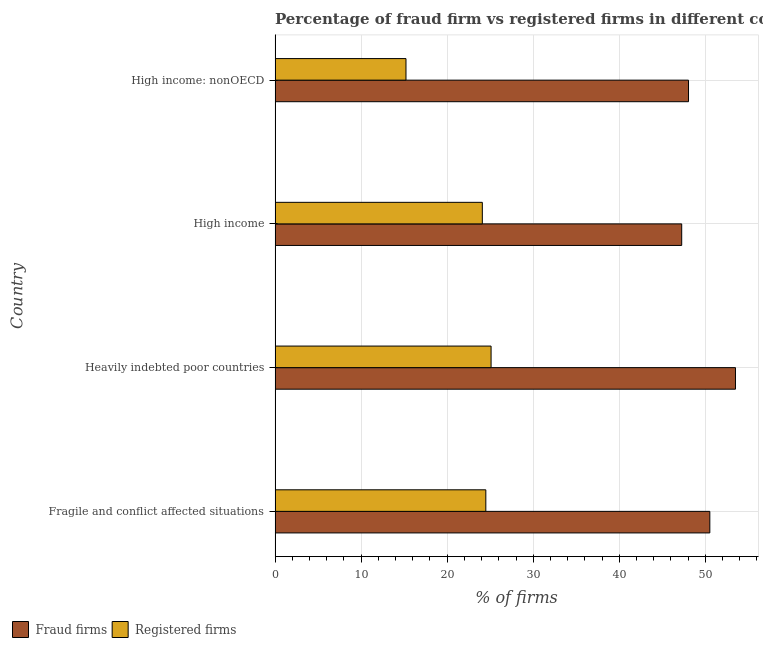How many different coloured bars are there?
Ensure brevity in your answer.  2. How many groups of bars are there?
Offer a terse response. 4. How many bars are there on the 3rd tick from the top?
Make the answer very short. 2. What is the label of the 3rd group of bars from the top?
Give a very brief answer. Heavily indebted poor countries. In how many cases, is the number of bars for a given country not equal to the number of legend labels?
Provide a succinct answer. 0. What is the percentage of registered firms in High income?
Offer a very short reply. 24.08. Across all countries, what is the maximum percentage of fraud firms?
Ensure brevity in your answer.  53.5. Across all countries, what is the minimum percentage of registered firms?
Keep it short and to the point. 15.21. In which country was the percentage of registered firms maximum?
Your response must be concise. Heavily indebted poor countries. In which country was the percentage of fraud firms minimum?
Your answer should be compact. High income. What is the total percentage of registered firms in the graph?
Provide a succinct answer. 88.89. What is the difference between the percentage of fraud firms in High income and that in High income: nonOECD?
Give a very brief answer. -0.79. What is the difference between the percentage of registered firms in High income and the percentage of fraud firms in Heavily indebted poor countries?
Your answer should be compact. -29.42. What is the average percentage of fraud firms per country?
Make the answer very short. 49.83. What is the difference between the percentage of fraud firms and percentage of registered firms in Heavily indebted poor countries?
Your response must be concise. 28.4. What is the ratio of the percentage of fraud firms in Heavily indebted poor countries to that in High income?
Keep it short and to the point. 1.13. Is the percentage of fraud firms in Fragile and conflict affected situations less than that in Heavily indebted poor countries?
Make the answer very short. Yes. What is the difference between the highest and the second highest percentage of registered firms?
Ensure brevity in your answer.  0.61. What is the difference between the highest and the lowest percentage of registered firms?
Offer a very short reply. 9.89. In how many countries, is the percentage of fraud firms greater than the average percentage of fraud firms taken over all countries?
Your answer should be compact. 2. Is the sum of the percentage of registered firms in Heavily indebted poor countries and High income greater than the maximum percentage of fraud firms across all countries?
Your answer should be very brief. No. What does the 1st bar from the top in Fragile and conflict affected situations represents?
Offer a very short reply. Registered firms. What does the 1st bar from the bottom in High income: nonOECD represents?
Provide a succinct answer. Fraud firms. How many bars are there?
Your response must be concise. 8. How many countries are there in the graph?
Make the answer very short. 4. Are the values on the major ticks of X-axis written in scientific E-notation?
Your answer should be compact. No. Does the graph contain any zero values?
Give a very brief answer. No. Does the graph contain grids?
Keep it short and to the point. Yes. Where does the legend appear in the graph?
Your answer should be compact. Bottom left. How many legend labels are there?
Offer a terse response. 2. What is the title of the graph?
Your answer should be very brief. Percentage of fraud firm vs registered firms in different countries. What is the label or title of the X-axis?
Make the answer very short. % of firms. What is the % of firms of Fraud firms in Fragile and conflict affected situations?
Your answer should be very brief. 50.52. What is the % of firms in Registered firms in Fragile and conflict affected situations?
Your answer should be very brief. 24.49. What is the % of firms in Fraud firms in Heavily indebted poor countries?
Provide a short and direct response. 53.5. What is the % of firms in Registered firms in Heavily indebted poor countries?
Give a very brief answer. 25.1. What is the % of firms of Fraud firms in High income?
Ensure brevity in your answer.  47.25. What is the % of firms in Registered firms in High income?
Your answer should be compact. 24.08. What is the % of firms in Fraud firms in High income: nonOECD?
Your answer should be very brief. 48.04. What is the % of firms in Registered firms in High income: nonOECD?
Provide a succinct answer. 15.21. Across all countries, what is the maximum % of firms in Fraud firms?
Your answer should be compact. 53.5. Across all countries, what is the maximum % of firms in Registered firms?
Your answer should be very brief. 25.1. Across all countries, what is the minimum % of firms of Fraud firms?
Offer a terse response. 47.25. Across all countries, what is the minimum % of firms in Registered firms?
Ensure brevity in your answer.  15.21. What is the total % of firms in Fraud firms in the graph?
Keep it short and to the point. 199.31. What is the total % of firms in Registered firms in the graph?
Keep it short and to the point. 88.89. What is the difference between the % of firms of Fraud firms in Fragile and conflict affected situations and that in Heavily indebted poor countries?
Keep it short and to the point. -2.98. What is the difference between the % of firms of Registered firms in Fragile and conflict affected situations and that in Heavily indebted poor countries?
Your answer should be very brief. -0.61. What is the difference between the % of firms in Fraud firms in Fragile and conflict affected situations and that in High income?
Ensure brevity in your answer.  3.27. What is the difference between the % of firms in Registered firms in Fragile and conflict affected situations and that in High income?
Offer a very short reply. 0.41. What is the difference between the % of firms of Fraud firms in Fragile and conflict affected situations and that in High income: nonOECD?
Ensure brevity in your answer.  2.48. What is the difference between the % of firms of Registered firms in Fragile and conflict affected situations and that in High income: nonOECD?
Give a very brief answer. 9.28. What is the difference between the % of firms of Fraud firms in Heavily indebted poor countries and that in High income?
Keep it short and to the point. 6.25. What is the difference between the % of firms of Registered firms in Heavily indebted poor countries and that in High income?
Provide a succinct answer. 1.02. What is the difference between the % of firms in Fraud firms in Heavily indebted poor countries and that in High income: nonOECD?
Your answer should be very brief. 5.46. What is the difference between the % of firms in Registered firms in Heavily indebted poor countries and that in High income: nonOECD?
Give a very brief answer. 9.89. What is the difference between the % of firms of Fraud firms in High income and that in High income: nonOECD?
Provide a succinct answer. -0.79. What is the difference between the % of firms of Registered firms in High income and that in High income: nonOECD?
Ensure brevity in your answer.  8.87. What is the difference between the % of firms in Fraud firms in Fragile and conflict affected situations and the % of firms in Registered firms in Heavily indebted poor countries?
Offer a terse response. 25.42. What is the difference between the % of firms in Fraud firms in Fragile and conflict affected situations and the % of firms in Registered firms in High income?
Provide a short and direct response. 26.44. What is the difference between the % of firms of Fraud firms in Fragile and conflict affected situations and the % of firms of Registered firms in High income: nonOECD?
Offer a very short reply. 35.31. What is the difference between the % of firms of Fraud firms in Heavily indebted poor countries and the % of firms of Registered firms in High income?
Give a very brief answer. 29.42. What is the difference between the % of firms of Fraud firms in Heavily indebted poor countries and the % of firms of Registered firms in High income: nonOECD?
Your answer should be very brief. 38.29. What is the difference between the % of firms of Fraud firms in High income and the % of firms of Registered firms in High income: nonOECD?
Offer a terse response. 32.04. What is the average % of firms of Fraud firms per country?
Ensure brevity in your answer.  49.83. What is the average % of firms in Registered firms per country?
Offer a terse response. 22.22. What is the difference between the % of firms in Fraud firms and % of firms in Registered firms in Fragile and conflict affected situations?
Your response must be concise. 26.03. What is the difference between the % of firms in Fraud firms and % of firms in Registered firms in Heavily indebted poor countries?
Provide a short and direct response. 28.4. What is the difference between the % of firms in Fraud firms and % of firms in Registered firms in High income?
Provide a succinct answer. 23.17. What is the difference between the % of firms in Fraud firms and % of firms in Registered firms in High income: nonOECD?
Ensure brevity in your answer.  32.83. What is the ratio of the % of firms in Fraud firms in Fragile and conflict affected situations to that in Heavily indebted poor countries?
Ensure brevity in your answer.  0.94. What is the ratio of the % of firms in Registered firms in Fragile and conflict affected situations to that in Heavily indebted poor countries?
Offer a terse response. 0.98. What is the ratio of the % of firms of Fraud firms in Fragile and conflict affected situations to that in High income?
Give a very brief answer. 1.07. What is the ratio of the % of firms in Registered firms in Fragile and conflict affected situations to that in High income?
Provide a succinct answer. 1.02. What is the ratio of the % of firms in Fraud firms in Fragile and conflict affected situations to that in High income: nonOECD?
Provide a short and direct response. 1.05. What is the ratio of the % of firms in Registered firms in Fragile and conflict affected situations to that in High income: nonOECD?
Offer a terse response. 1.61. What is the ratio of the % of firms in Fraud firms in Heavily indebted poor countries to that in High income?
Make the answer very short. 1.13. What is the ratio of the % of firms of Registered firms in Heavily indebted poor countries to that in High income?
Give a very brief answer. 1.04. What is the ratio of the % of firms of Fraud firms in Heavily indebted poor countries to that in High income: nonOECD?
Make the answer very short. 1.11. What is the ratio of the % of firms of Registered firms in Heavily indebted poor countries to that in High income: nonOECD?
Provide a succinct answer. 1.65. What is the ratio of the % of firms in Fraud firms in High income to that in High income: nonOECD?
Provide a succinct answer. 0.98. What is the ratio of the % of firms of Registered firms in High income to that in High income: nonOECD?
Make the answer very short. 1.58. What is the difference between the highest and the second highest % of firms of Fraud firms?
Provide a short and direct response. 2.98. What is the difference between the highest and the second highest % of firms in Registered firms?
Keep it short and to the point. 0.61. What is the difference between the highest and the lowest % of firms in Fraud firms?
Your response must be concise. 6.25. What is the difference between the highest and the lowest % of firms in Registered firms?
Provide a succinct answer. 9.89. 